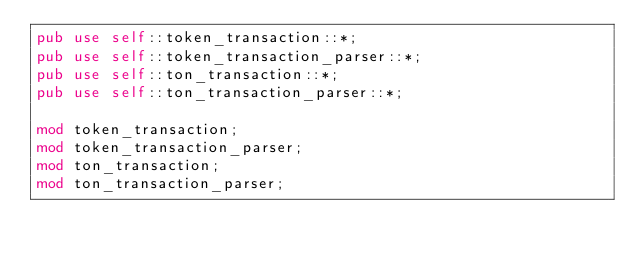Convert code to text. <code><loc_0><loc_0><loc_500><loc_500><_Rust_>pub use self::token_transaction::*;
pub use self::token_transaction_parser::*;
pub use self::ton_transaction::*;
pub use self::ton_transaction_parser::*;

mod token_transaction;
mod token_transaction_parser;
mod ton_transaction;
mod ton_transaction_parser;
</code> 